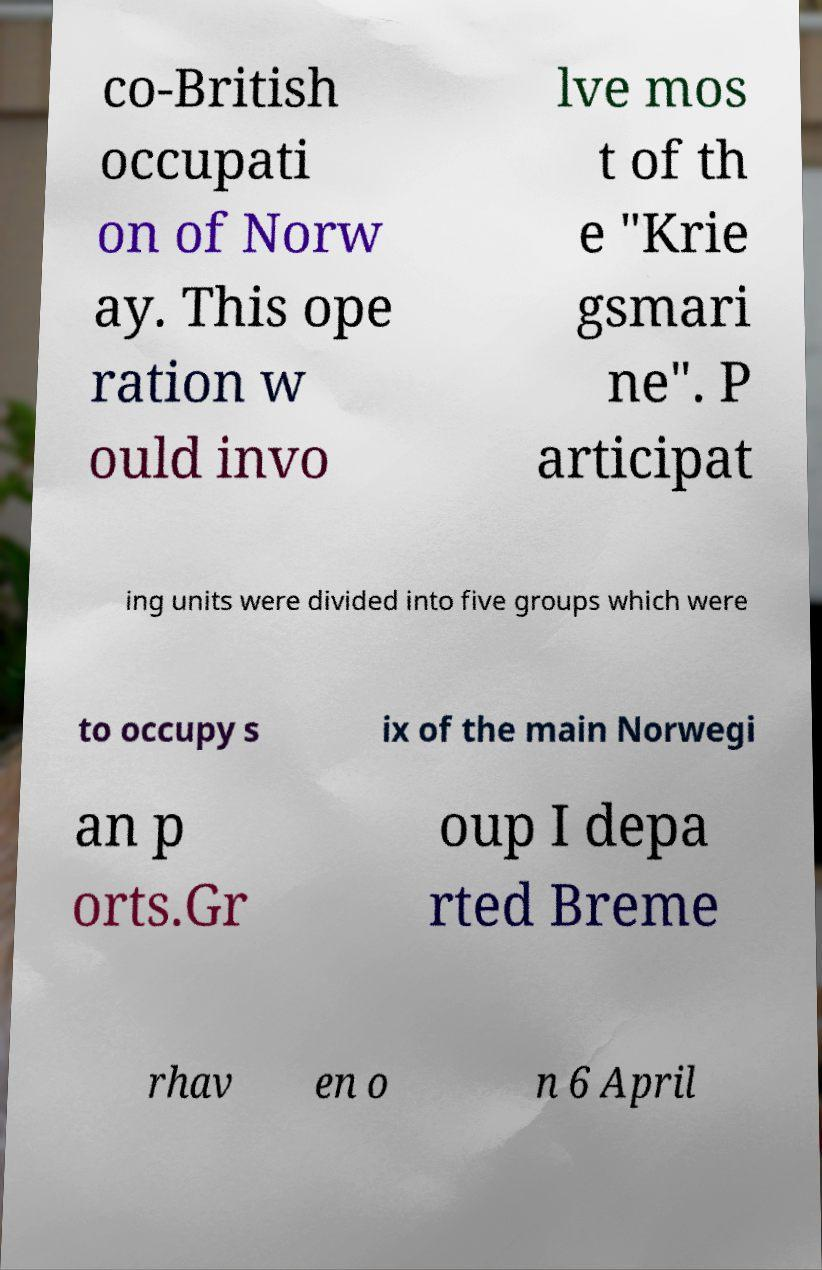Could you extract and type out the text from this image? co-British occupati on of Norw ay. This ope ration w ould invo lve mos t of th e "Krie gsmari ne". P articipat ing units were divided into five groups which were to occupy s ix of the main Norwegi an p orts.Gr oup I depa rted Breme rhav en o n 6 April 